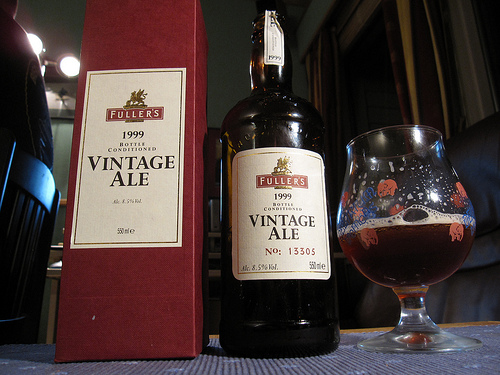<image>
Can you confirm if the wine is under the bottle? No. The wine is not positioned under the bottle. The vertical relationship between these objects is different. Where is the beer bottle in relation to the curtain? Is it in front of the curtain? Yes. The beer bottle is positioned in front of the curtain, appearing closer to the camera viewpoint. 